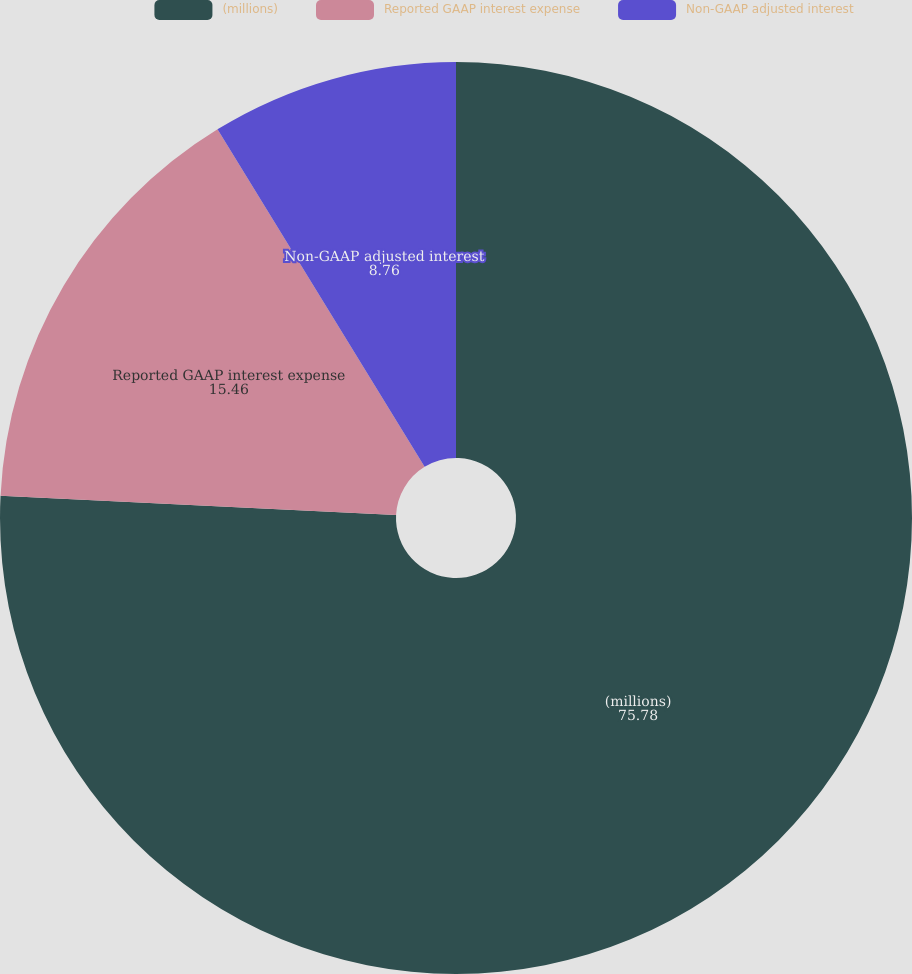Convert chart. <chart><loc_0><loc_0><loc_500><loc_500><pie_chart><fcel>(millions)<fcel>Reported GAAP interest expense<fcel>Non-GAAP adjusted interest<nl><fcel>75.78%<fcel>15.46%<fcel>8.76%<nl></chart> 